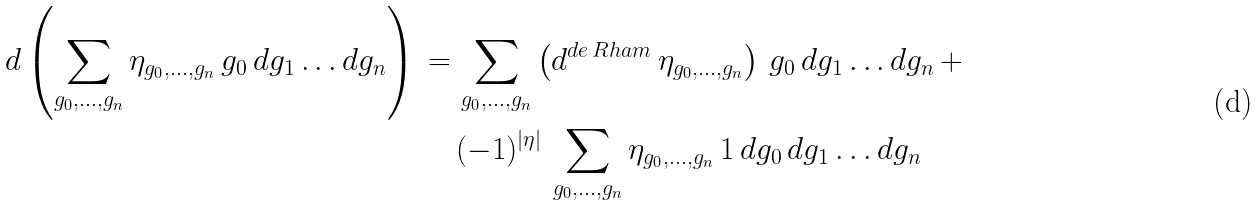Convert formula to latex. <formula><loc_0><loc_0><loc_500><loc_500>d \left ( \sum _ { g _ { 0 } , \dots , g _ { n } } \eta _ { g _ { 0 } , \dots , g _ { n } } \, g _ { 0 } \, d g _ { 1 } \dots d g _ { n } \right ) \, = \, & \sum _ { g _ { 0 } , \dots , g _ { n } } \left ( d ^ { d e \, R h a m } \, \eta _ { g _ { 0 } , \dots , g _ { n } } \right ) \, g _ { 0 } \, d g _ { 1 } \dots d g _ { n } \, + \\ & ( - 1 ) ^ { | \eta | } \, \sum _ { g _ { 0 } , \dots , g _ { n } } \eta _ { g _ { 0 } , \dots , g _ { n } } \, 1 \, d g _ { 0 } \, d g _ { 1 } \dots d g _ { n }</formula> 